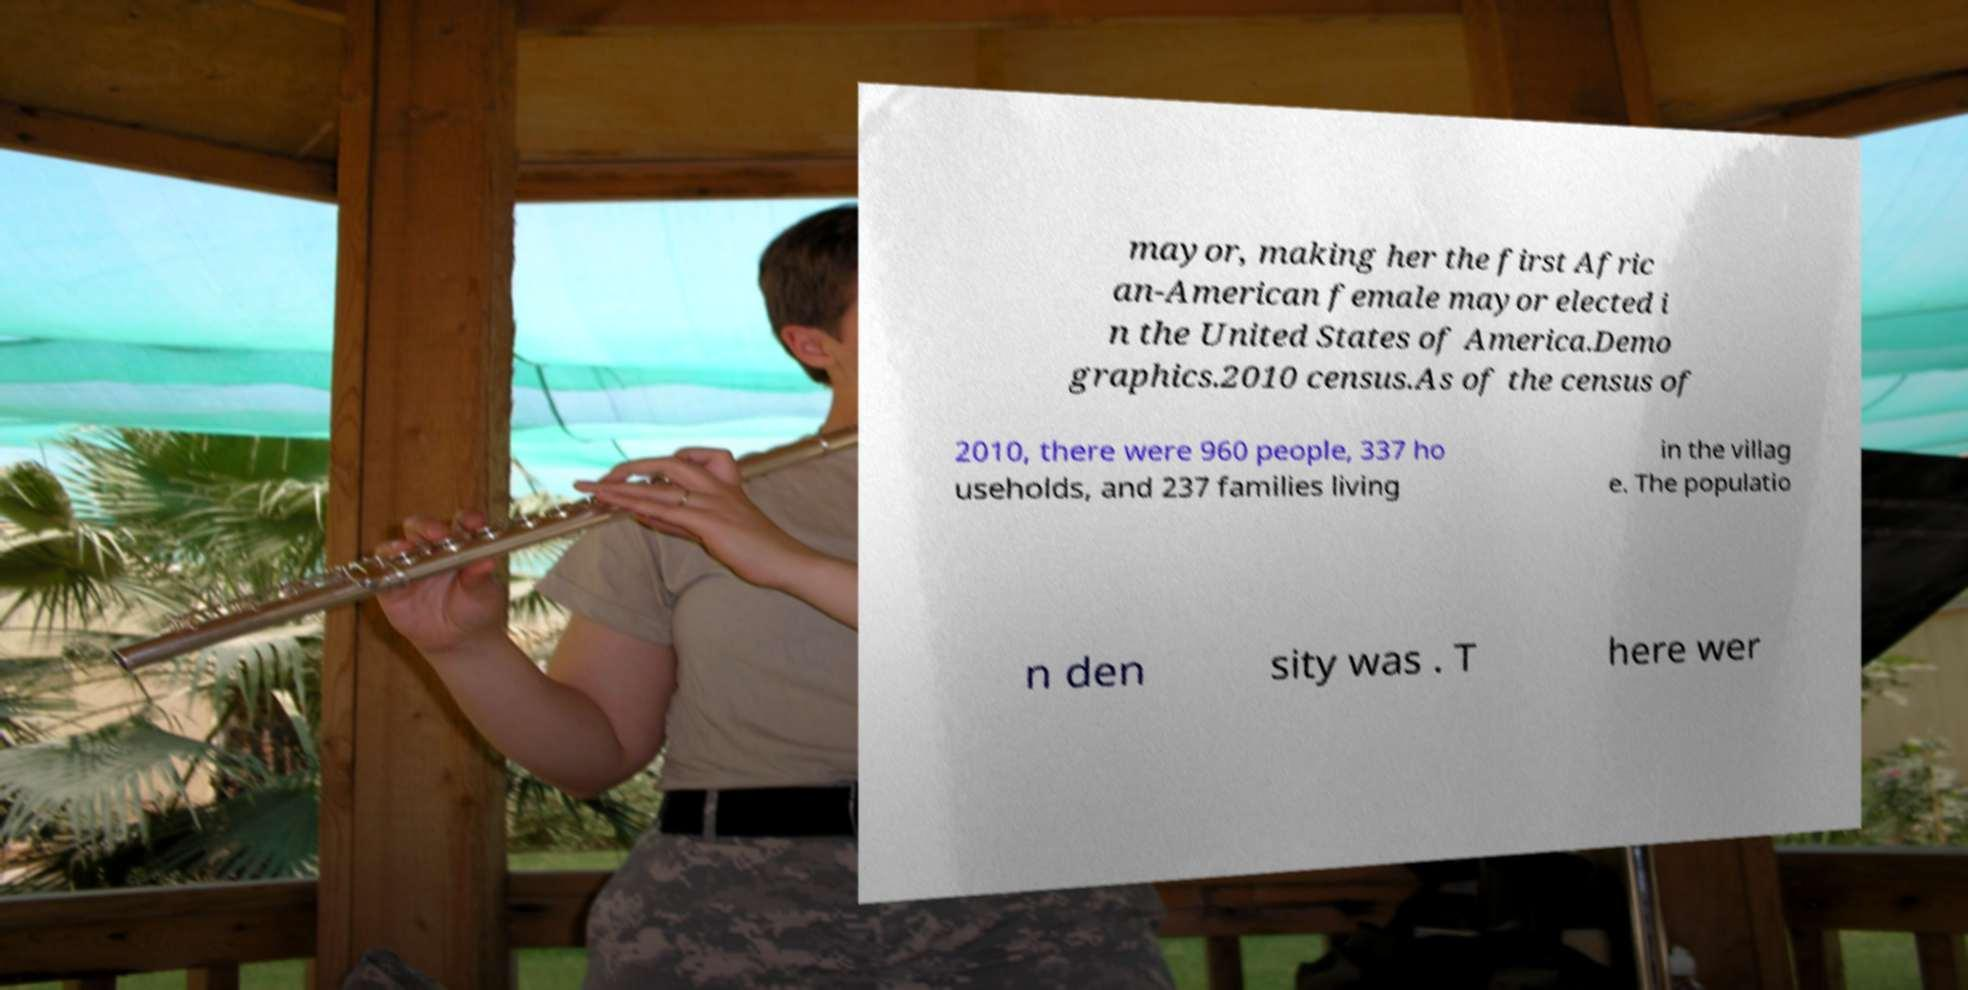Can you read and provide the text displayed in the image?This photo seems to have some interesting text. Can you extract and type it out for me? mayor, making her the first Afric an-American female mayor elected i n the United States of America.Demo graphics.2010 census.As of the census of 2010, there were 960 people, 337 ho useholds, and 237 families living in the villag e. The populatio n den sity was . T here wer 